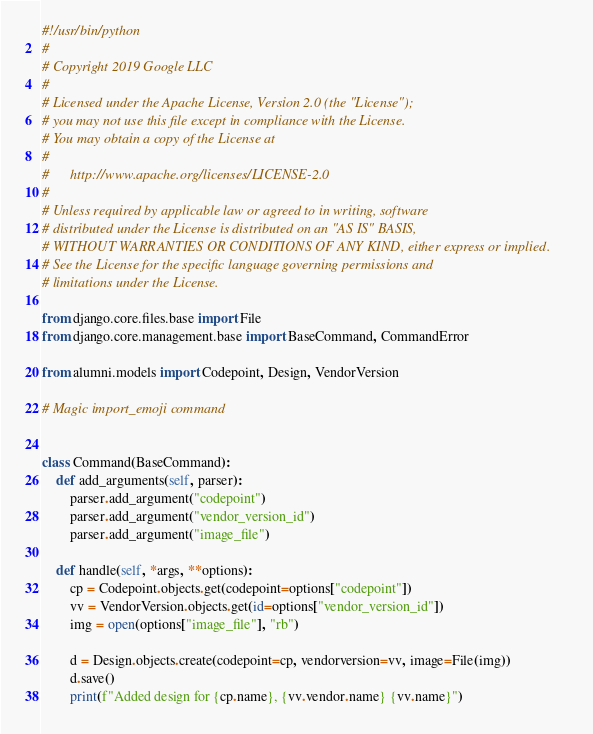Convert code to text. <code><loc_0><loc_0><loc_500><loc_500><_Python_>#!/usr/bin/python
#
# Copyright 2019 Google LLC
#
# Licensed under the Apache License, Version 2.0 (the "License");
# you may not use this file except in compliance with the License.
# You may obtain a copy of the License at
#
#      http://www.apache.org/licenses/LICENSE-2.0
#
# Unless required by applicable law or agreed to in writing, software
# distributed under the License is distributed on an "AS IS" BASIS,
# WITHOUT WARRANTIES OR CONDITIONS OF ANY KIND, either express or implied.
# See the License for the specific language governing permissions and
# limitations under the License.

from django.core.files.base import File
from django.core.management.base import BaseCommand, CommandError

from alumni.models import Codepoint, Design, VendorVersion

# Magic import_emoji command


class Command(BaseCommand):
    def add_arguments(self, parser):
        parser.add_argument("codepoint")
        parser.add_argument("vendor_version_id")
        parser.add_argument("image_file")

    def handle(self, *args, **options):
        cp = Codepoint.objects.get(codepoint=options["codepoint"])
        vv = VendorVersion.objects.get(id=options["vendor_version_id"])
        img = open(options["image_file"], "rb")

        d = Design.objects.create(codepoint=cp, vendorversion=vv, image=File(img))
        d.save()
        print(f"Added design for {cp.name}, {vv.vendor.name} {vv.name}")
</code> 